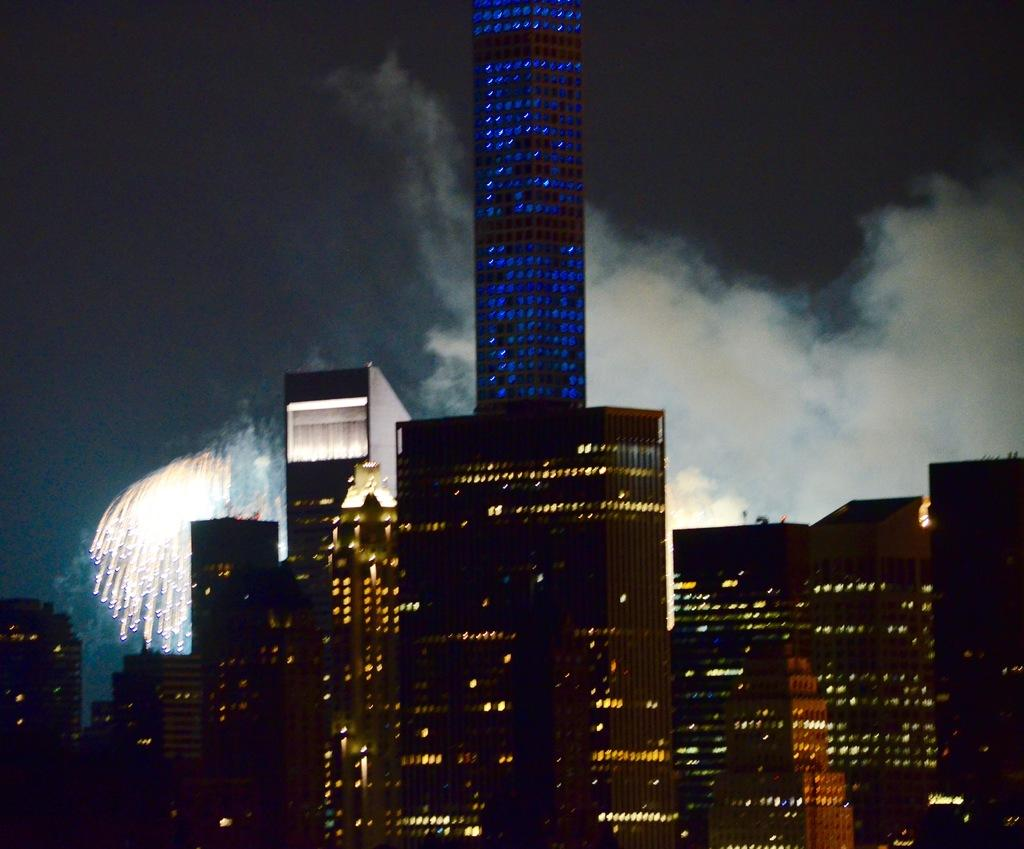What type of structures can be seen in the image? There are buildings in the image. What can be seen illuminated in the image? There are lights visible in the image. What is happening in the background of the image? There are fireworks and smoke in the background of the image. What part of the natural environment is visible in the image? The sky is visible in the image. Where is the harbor located in the image? There is no harbor present in the image. How many kittens can be seen playing with the train in the image? There are no kittens or trains present in the image. 